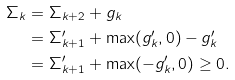<formula> <loc_0><loc_0><loc_500><loc_500>\Sigma _ { k } & = \Sigma _ { k + 2 } + g _ { k } \\ & = \Sigma ^ { \prime } _ { k + 1 } + \max ( g ^ { \prime } _ { k } , 0 ) - g ^ { \prime } _ { k } \\ & = \Sigma ^ { \prime } _ { k + 1 } + \max ( - g ^ { \prime } _ { k } , 0 ) \geq 0 .</formula> 